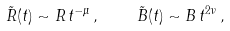<formula> <loc_0><loc_0><loc_500><loc_500>\tilde { R } ( t ) \sim R \, t ^ { - \mu } \, , \quad \tilde { B } ( t ) \sim B \, t ^ { 2 \nu } \, ,</formula> 